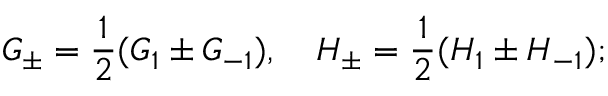Convert formula to latex. <formula><loc_0><loc_0><loc_500><loc_500>G _ { \pm } = \frac { 1 } { 2 } ( G _ { 1 } \pm G _ { - 1 } ) , \quad H _ { \pm } = \frac { 1 } { 2 } ( H _ { 1 } \pm H _ { - 1 } ) ;</formula> 